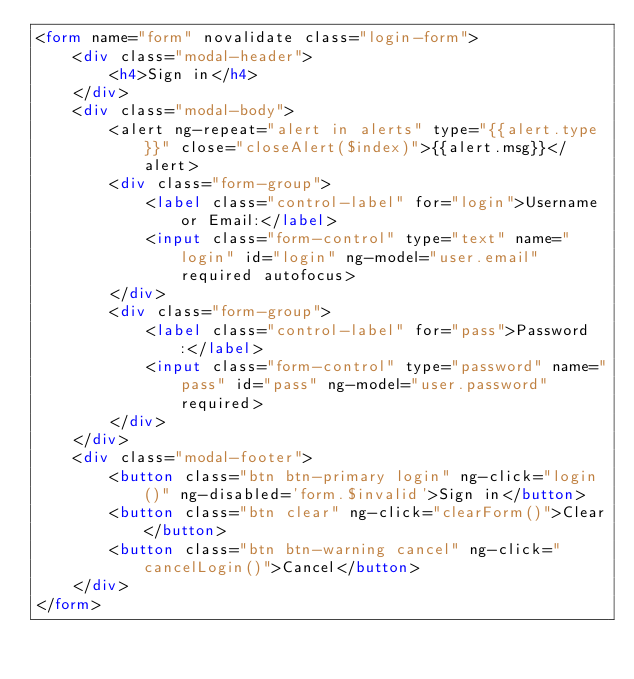<code> <loc_0><loc_0><loc_500><loc_500><_HTML_><form name="form" novalidate class="login-form">
    <div class="modal-header">
        <h4>Sign in</h4>
    </div>
    <div class="modal-body">
        <alert ng-repeat="alert in alerts" type="{{alert.type}}" close="closeAlert($index)">{{alert.msg}}</alert>
        <div class="form-group">
            <label class="control-label" for="login">Username or Email:</label>
            <input class="form-control" type="text" name="login" id="login" ng-model="user.email" required autofocus>
        </div>
        <div class="form-group">
            <label class="control-label" for="pass">Password:</label>
            <input class="form-control" type="password" name="pass" id="pass" ng-model="user.password" required>
        </div>
    </div>
    <div class="modal-footer">
        <button class="btn btn-primary login" ng-click="login()" ng-disabled='form.$invalid'>Sign in</button>
        <button class="btn clear" ng-click="clearForm()">Clear</button>
        <button class="btn btn-warning cancel" ng-click="cancelLogin()">Cancel</button>
    </div>
</form>
</code> 